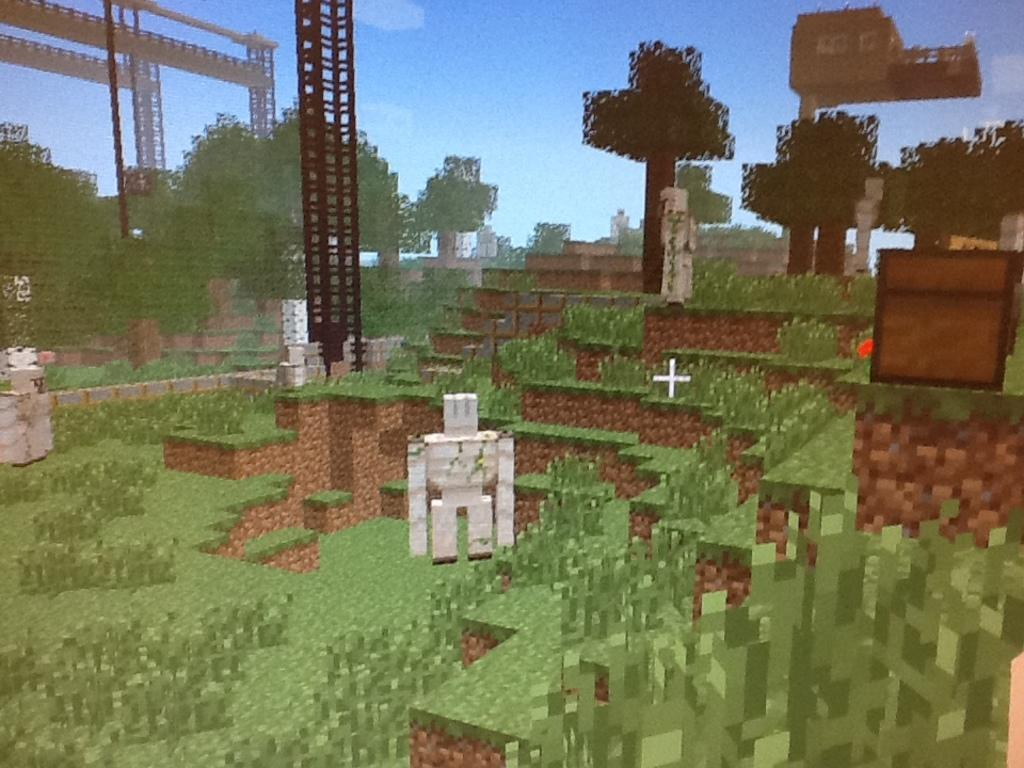What type of structures can be seen in the image? There are trusses in the image. What type of vegetation is present in the image? There are trees and grass in the image. Can you describe the object in the image? There is an object in the image, but its specific nature is not clear from the provided facts. What is visible in the background of the image? The sky is visible in the image. How many rats are sitting on the trusses in the image? There are no rats present in the image; it features trusses, trees, grass, an object, and the sky. What type of cattle can be seen grazing in the grass in the image? There are no cattle present in the image; it features trusses, trees, grass, an object, and the sky. 